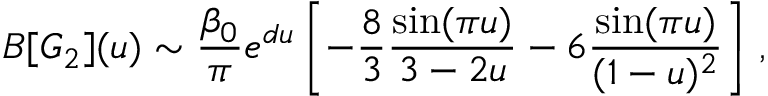<formula> <loc_0><loc_0><loc_500><loc_500>B [ G _ { 2 } ] ( u ) \sim { \frac { \beta _ { 0 } } { \pi } } e ^ { d u } \left [ - { \frac { 8 } { 3 } } { \frac { \sin ( \pi u ) } { 3 - 2 u } } - 6 { \frac { \sin ( \pi u ) } { ( 1 - u ) ^ { 2 } } } \right ] \, ,</formula> 